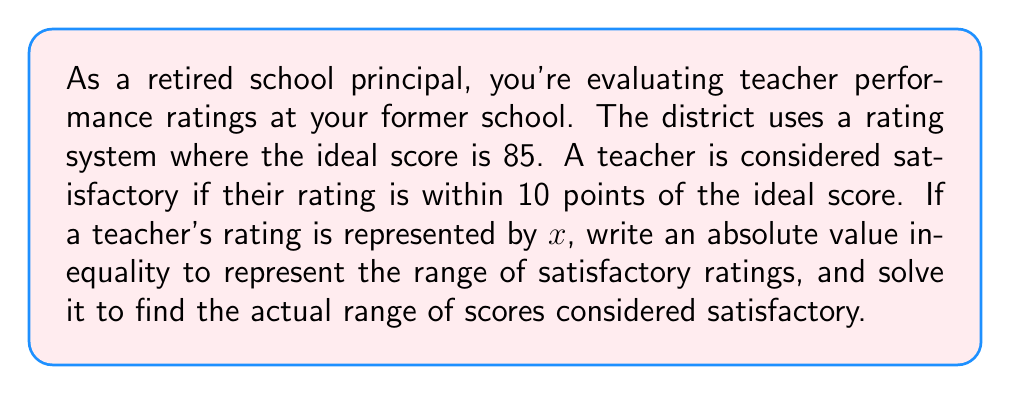Provide a solution to this math problem. Let's approach this step-by-step:

1) The ideal score is 85, and a satisfactory rating is within 10 points of this ideal.

2) We can represent this situation with an absolute value inequality:
   $$|x - 85| \leq 10$$

   This reads as "the absolute difference between x and 85 is less than or equal to 10."

3) To solve this inequality, we need to consider two cases:

   Case 1: $x - 85 \leq 10$
   Case 2: $x - 85 \geq -10$

4) Solving Case 1:
   $$x - 85 \leq 10$$
   $$x \leq 95$$

5) Solving Case 2:
   $$x - 85 \geq -10$$
   $$x \geq 75$$

6) Combining the results from steps 4 and 5, we get:
   $$75 \leq x \leq 95$$

This means that any rating $x$ between 75 and 95, inclusive, is considered satisfactory.
Answer: The absolute value inequality representing satisfactory ratings is $|x - 85| \leq 10$, and the range of satisfactory scores is $75 \leq x \leq 95$. 